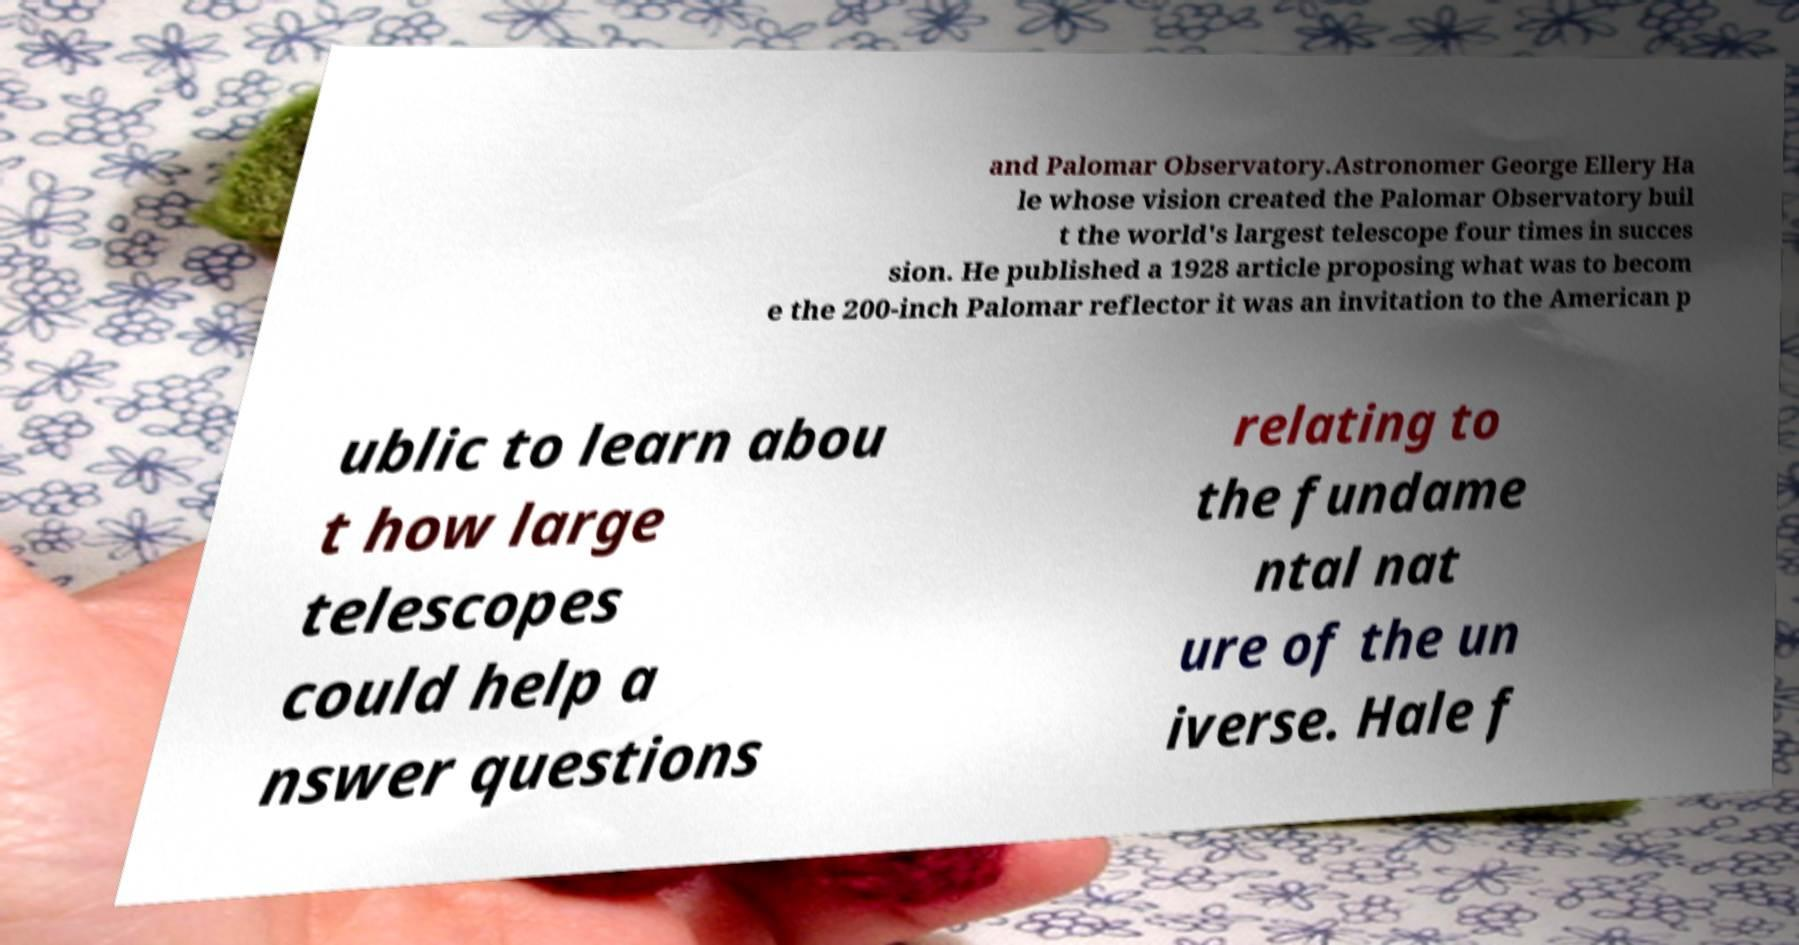Can you accurately transcribe the text from the provided image for me? and Palomar Observatory.Astronomer George Ellery Ha le whose vision created the Palomar Observatory buil t the world's largest telescope four times in succes sion. He published a 1928 article proposing what was to becom e the 200-inch Palomar reflector it was an invitation to the American p ublic to learn abou t how large telescopes could help a nswer questions relating to the fundame ntal nat ure of the un iverse. Hale f 